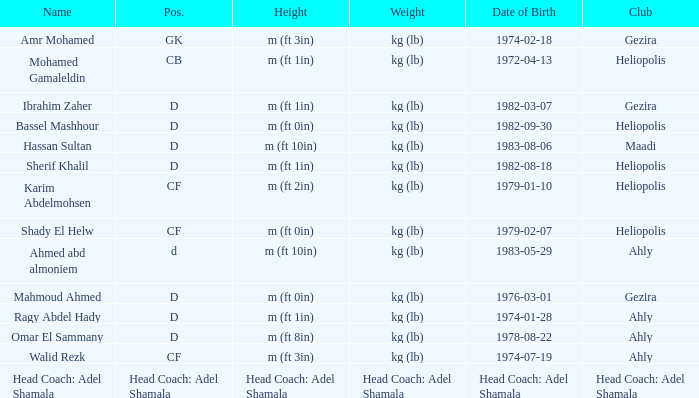For the individual with the height "head coach: adel shamala", what is their date of birth? Head Coach: Adel Shamala. 